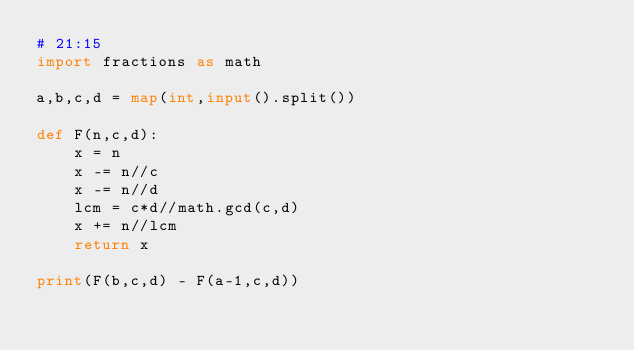<code> <loc_0><loc_0><loc_500><loc_500><_Python_># 21:15
import fractions as math

a,b,c,d = map(int,input().split())

def F(n,c,d):
    x = n
    x -= n//c
    x -= n//d
    lcm = c*d//math.gcd(c,d)
    x += n//lcm
    return x

print(F(b,c,d) - F(a-1,c,d))</code> 